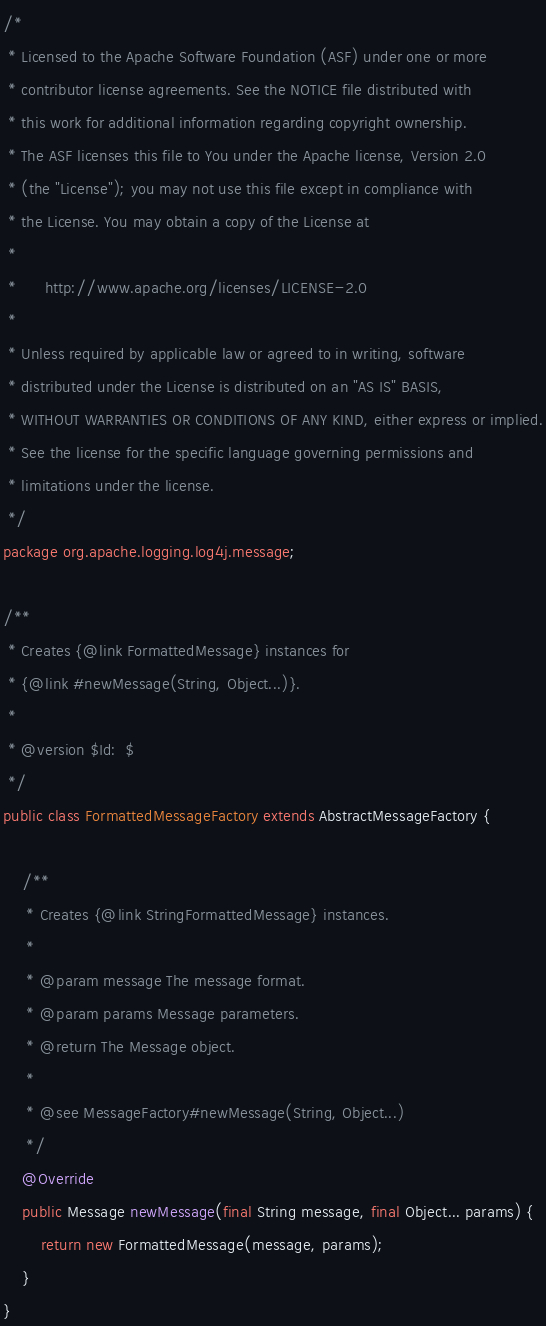<code> <loc_0><loc_0><loc_500><loc_500><_Java_>/*
 * Licensed to the Apache Software Foundation (ASF) under one or more
 * contributor license agreements. See the NOTICE file distributed with
 * this work for additional information regarding copyright ownership.
 * The ASF licenses this file to You under the Apache license, Version 2.0
 * (the "License"); you may not use this file except in compliance with
 * the License. You may obtain a copy of the License at
 *
 *      http://www.apache.org/licenses/LICENSE-2.0
 *
 * Unless required by applicable law or agreed to in writing, software
 * distributed under the License is distributed on an "AS IS" BASIS,
 * WITHOUT WARRANTIES OR CONDITIONS OF ANY KIND, either express or implied.
 * See the license for the specific language governing permissions and
 * limitations under the license.
 */
package org.apache.logging.log4j.message;

/**
 * Creates {@link FormattedMessage} instances for
 * {@link #newMessage(String, Object...)}.
 *
 * @version $Id:  $
 */
public class FormattedMessageFactory extends AbstractMessageFactory {

    /**
     * Creates {@link StringFormattedMessage} instances.
     *
     * @param message The message format.
     * @param params Message parameters.
     * @return The Message object.
     *
     * @see MessageFactory#newMessage(String, Object...)
     */
    @Override
    public Message newMessage(final String message, final Object... params) {
        return new FormattedMessage(message, params);
    }
}
</code> 